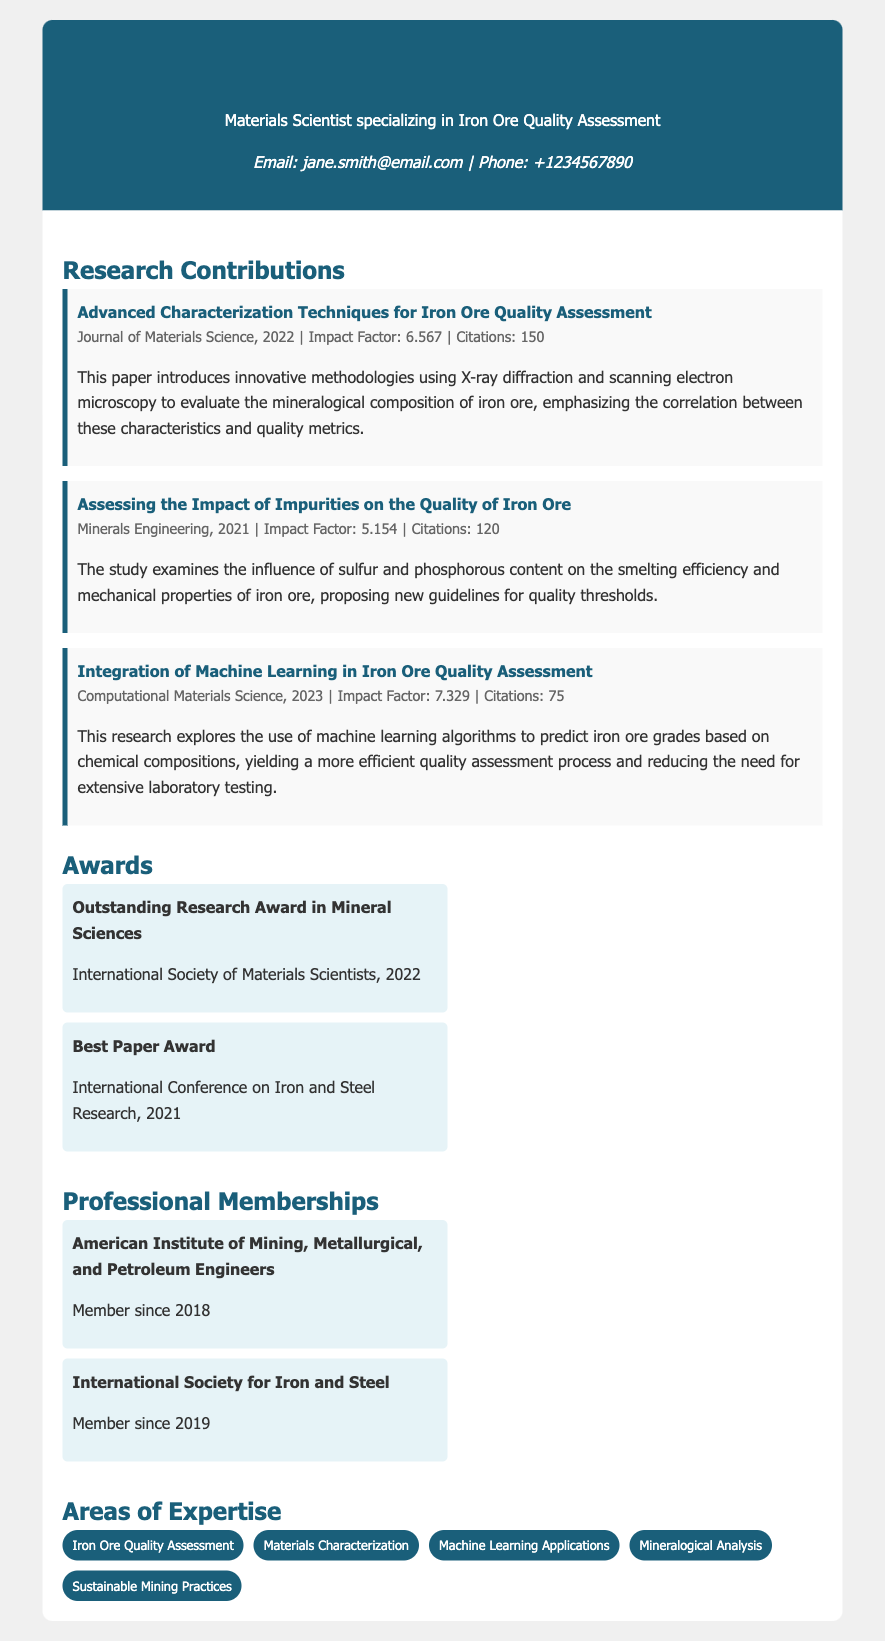What is Dr. Jane Smith's specialization? The specialization mentioned in the document is "Materials Scientist specializing in Iron Ore Quality Assessment."
Answer: Iron Ore Quality Assessment What is the title of the publication with the highest impact factor? The publication with the highest impact factor is "Integration of Machine Learning in Iron Ore Quality Assessment," which has an impact factor of 7.329.
Answer: Integration of Machine Learning in Iron Ore Quality Assessment How many citations does the paper on impurities have? The paper titled "Assessing the Impact of Impurities on the Quality of Iron Ore" has 120 citations listed in the document.
Answer: 120 Which organization awarded Dr. Smith the Outstanding Research Award? The document states that the Outstanding Research Award was given by the International Society of Materials Scientists.
Answer: International Society of Materials Scientists When did Dr. Smith become a member of the American Institute of Mining? The document indicates that Dr. Smith became a member in 2018.
Answer: 2018 What methodologies are introduced in the research on iron ore quality assessment? The methodologies introduced include "X-ray diffraction and scanning electron microscopy."
Answer: X-ray diffraction and scanning electron microscopy What year was the "Best Paper Award" given? According to the document, the "Best Paper Award" was awarded in 2021.
Answer: 2021 What is one area of expertise mentioned in the document? The document lists several areas of expertise and one of them is "Machine Learning Applications."
Answer: Machine Learning Applications What is the total number of awards mentioned in the resume? The document describes a total of two awards under the awards section.
Answer: 2 